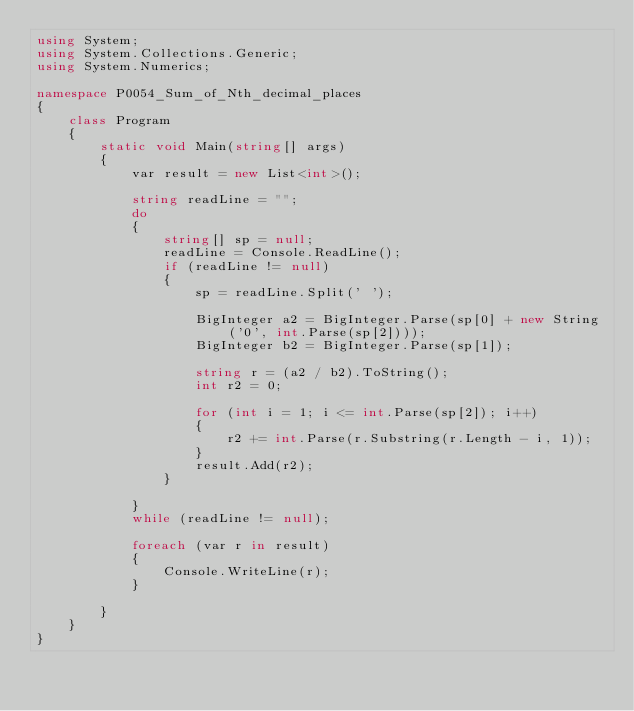Convert code to text. <code><loc_0><loc_0><loc_500><loc_500><_C#_>using System;
using System.Collections.Generic;
using System.Numerics;

namespace P0054_Sum_of_Nth_decimal_places
{
    class Program
    {
        static void Main(string[] args)
        {
            var result = new List<int>();

            string readLine = "";
            do
            {
                string[] sp = null;
                readLine = Console.ReadLine();
                if (readLine != null)
                {
                    sp = readLine.Split(' ');

                    BigInteger a2 = BigInteger.Parse(sp[0] + new String('0', int.Parse(sp[2])));
                    BigInteger b2 = BigInteger.Parse(sp[1]);

                    string r = (a2 / b2).ToString();
                    int r2 = 0;

                    for (int i = 1; i <= int.Parse(sp[2]); i++)
                    {
                        r2 += int.Parse(r.Substring(r.Length - i, 1));
                    }
                    result.Add(r2);
                }

            }
            while (readLine != null);

            foreach (var r in result) 
            {
                Console.WriteLine(r);
            }

        }
    }
}</code> 